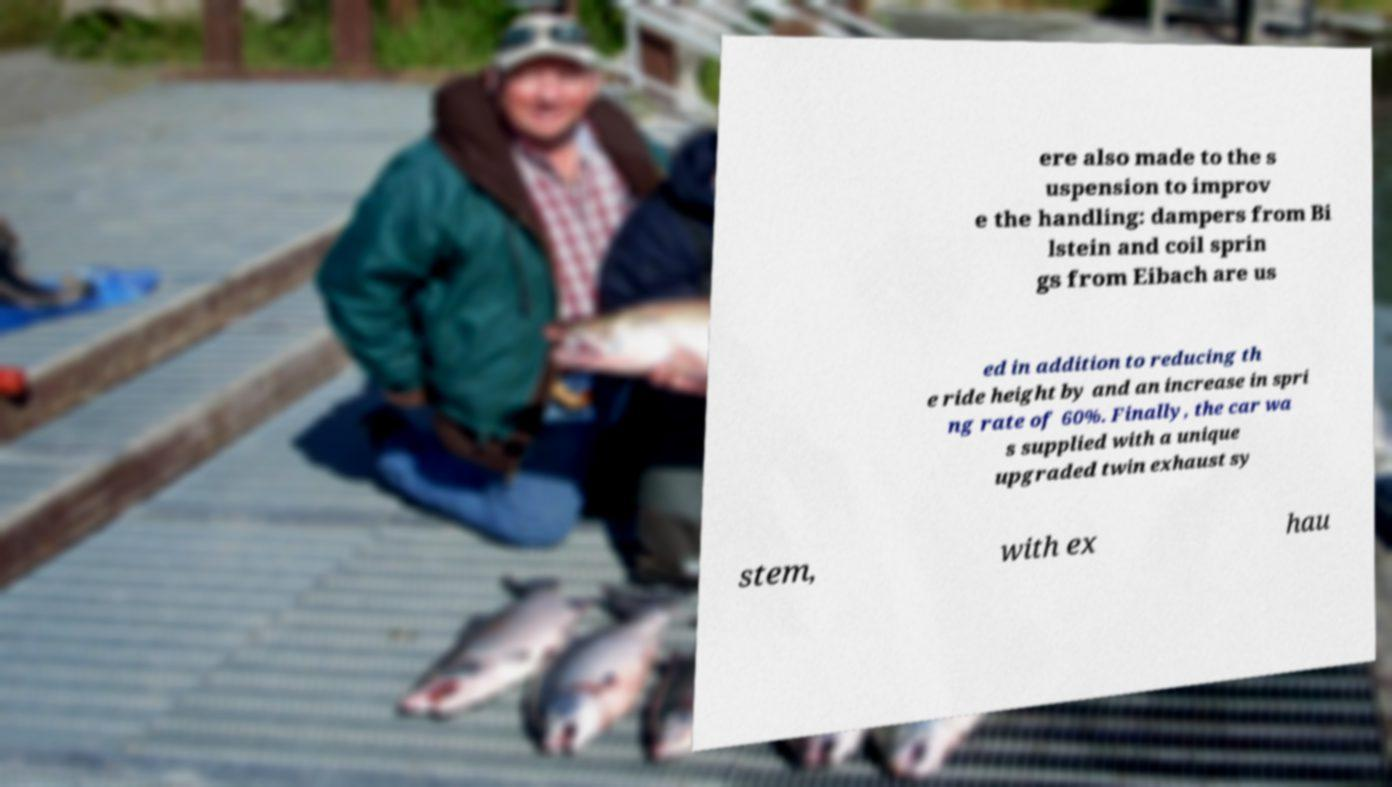Please read and relay the text visible in this image. What does it say? ere also made to the s uspension to improv e the handling: dampers from Bi lstein and coil sprin gs from Eibach are us ed in addition to reducing th e ride height by and an increase in spri ng rate of 60%. Finally, the car wa s supplied with a unique upgraded twin exhaust sy stem, with ex hau 